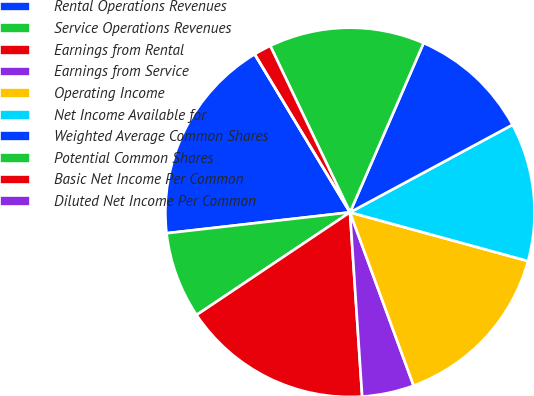<chart> <loc_0><loc_0><loc_500><loc_500><pie_chart><fcel>Rental Operations Revenues<fcel>Service Operations Revenues<fcel>Earnings from Rental<fcel>Earnings from Service<fcel>Operating Income<fcel>Net Income Available for<fcel>Weighted Average Common Shares<fcel>Potential Common Shares<fcel>Basic Net Income Per Common<fcel>Diluted Net Income Per Common<nl><fcel>18.18%<fcel>7.58%<fcel>16.67%<fcel>4.55%<fcel>15.15%<fcel>12.12%<fcel>10.61%<fcel>13.64%<fcel>1.52%<fcel>0.0%<nl></chart> 